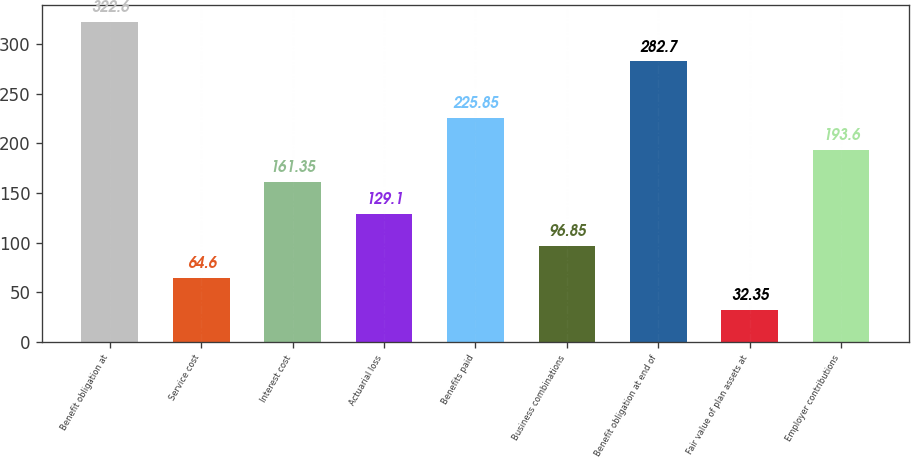Convert chart to OTSL. <chart><loc_0><loc_0><loc_500><loc_500><bar_chart><fcel>Benefit obligation at<fcel>Service cost<fcel>Interest cost<fcel>Actuarial loss<fcel>Benefits paid<fcel>Business combinations<fcel>Benefit obligation at end of<fcel>Fair value of plan assets at<fcel>Employer contributions<nl><fcel>322.6<fcel>64.6<fcel>161.35<fcel>129.1<fcel>225.85<fcel>96.85<fcel>282.7<fcel>32.35<fcel>193.6<nl></chart> 